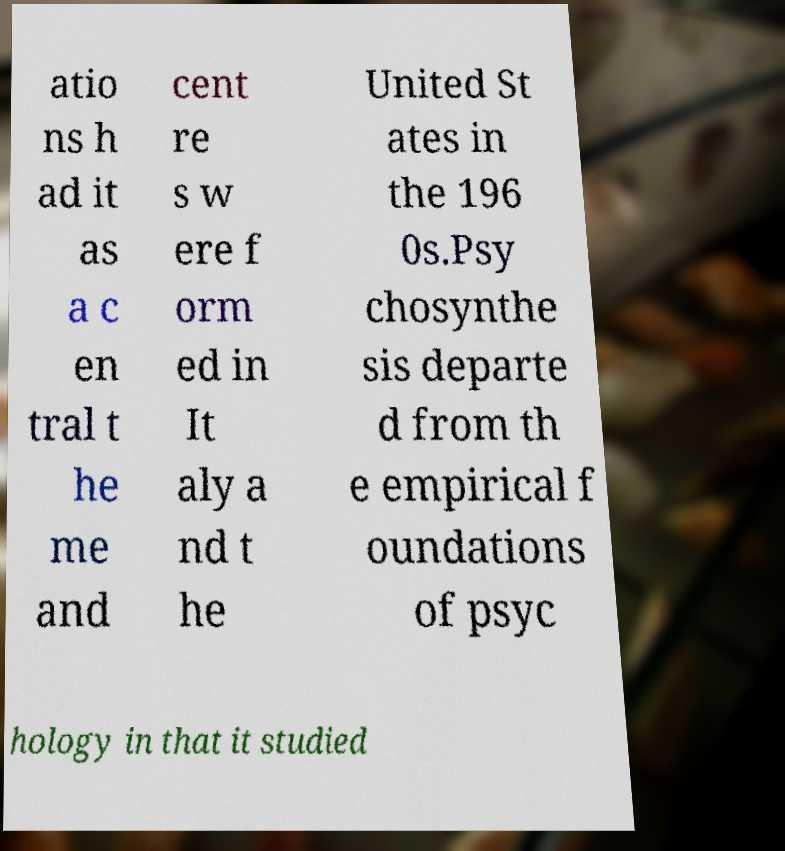What messages or text are displayed in this image? I need them in a readable, typed format. atio ns h ad it as a c en tral t he me and cent re s w ere f orm ed in It aly a nd t he United St ates in the 196 0s.Psy chosynthe sis departe d from th e empirical f oundations of psyc hology in that it studied 